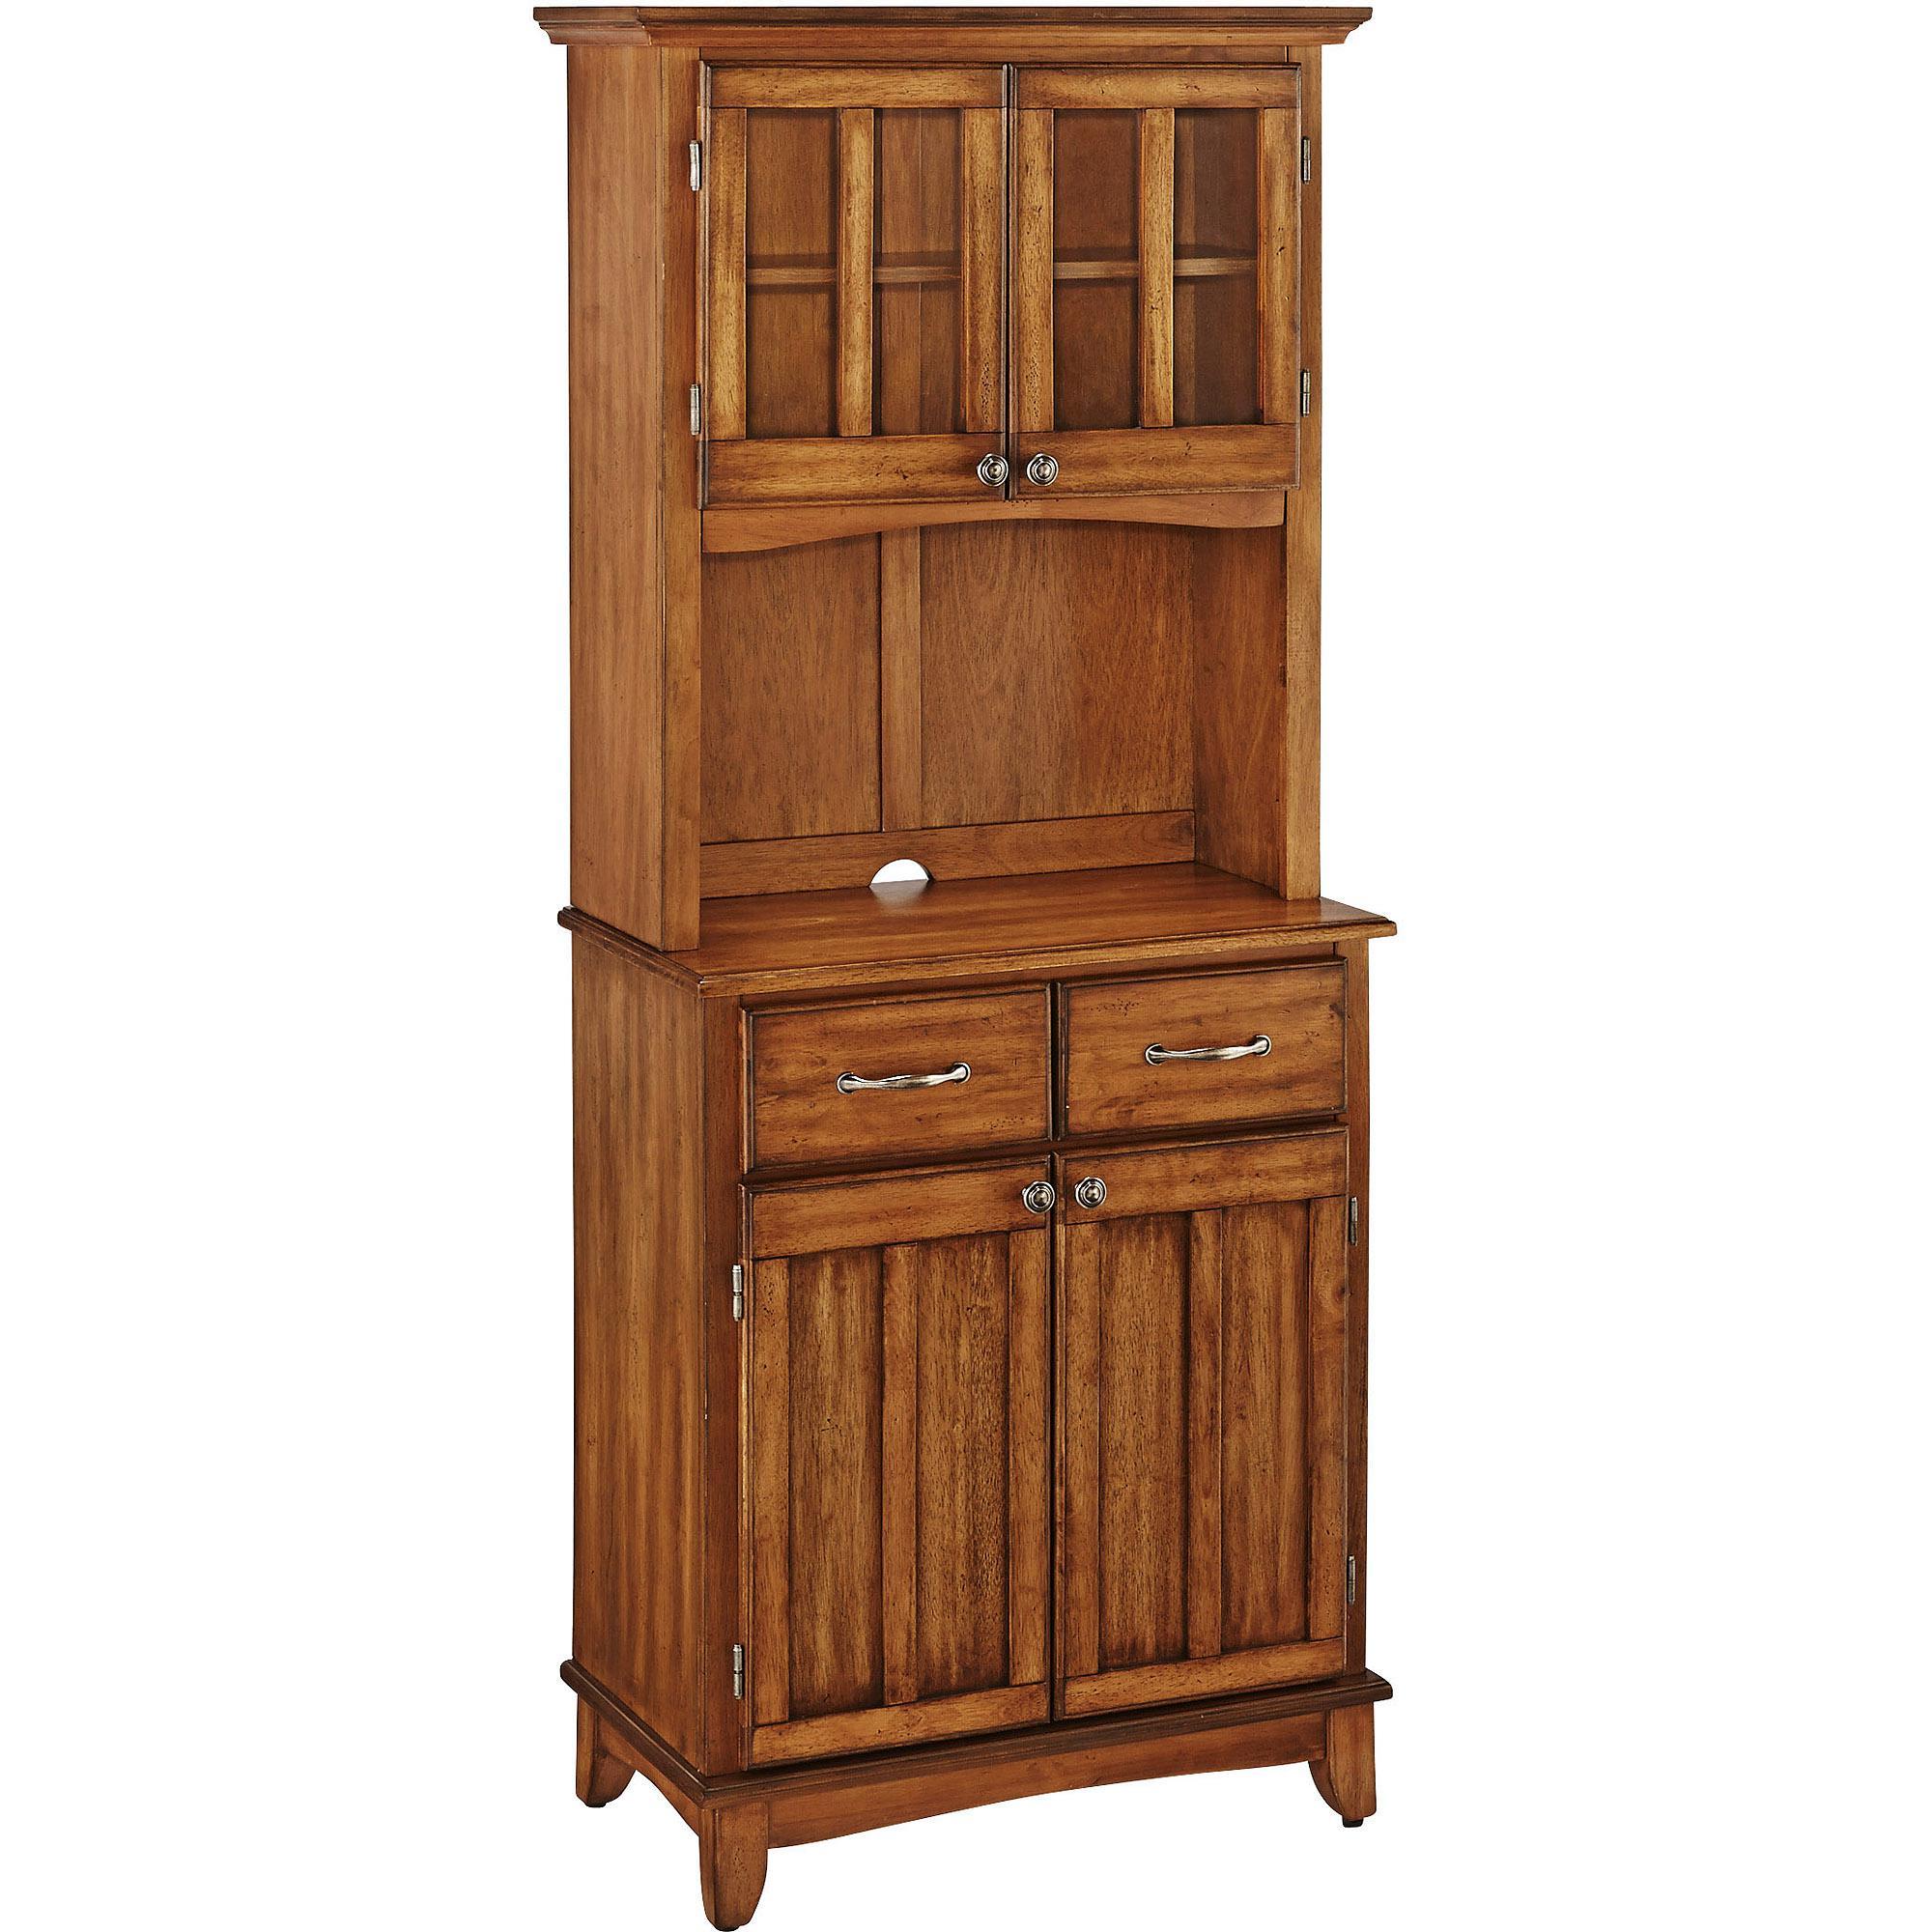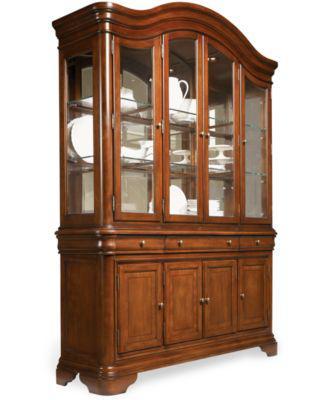The first image is the image on the left, the second image is the image on the right. Considering the images on both sides, is "An image shows a cabinet with a non-flat top and with feet." valid? Answer yes or no. Yes. The first image is the image on the left, the second image is the image on the right. Given the left and right images, does the statement "In one image, a wooden hutch sits on short legs and has three doors at the top, three at the bottom, and two drawers in the middle." hold true? Answer yes or no. No. 